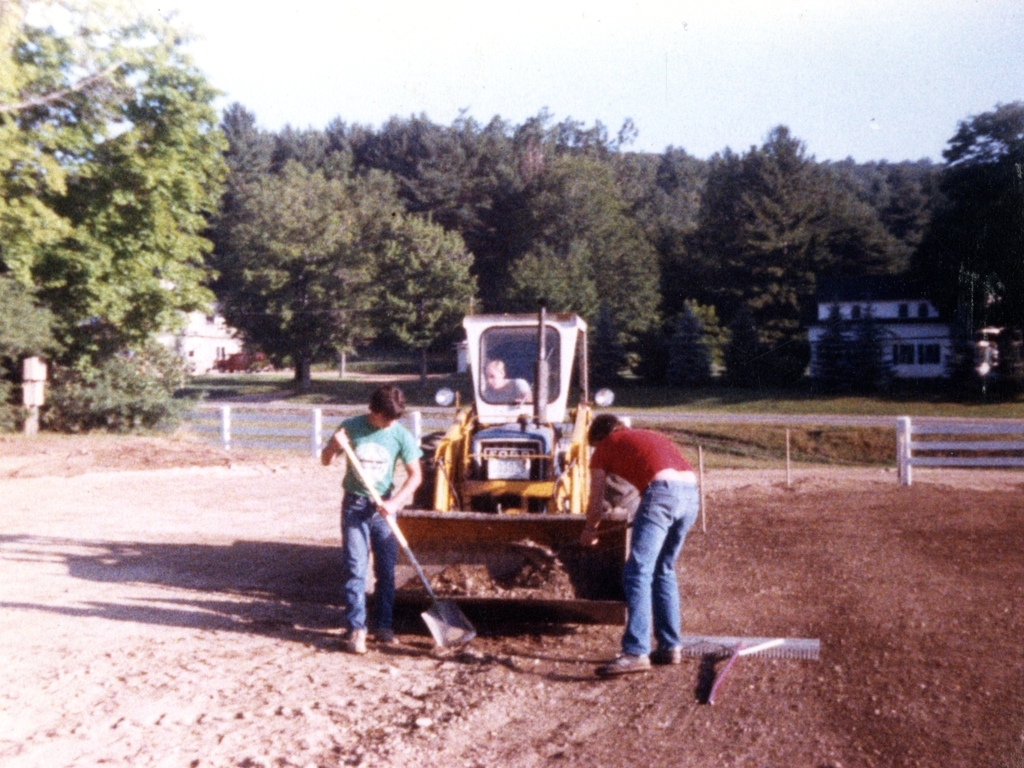What activity is being displayed in this image? The image shows three individuals engaged in construction-related work. Two individuals appear to be using shovels to move material, possibly gravel or dirt, while the third person is operating a yellow backhoe, aiding in the excavation or construction process. 